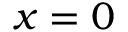Convert formula to latex. <formula><loc_0><loc_0><loc_500><loc_500>x = 0</formula> 